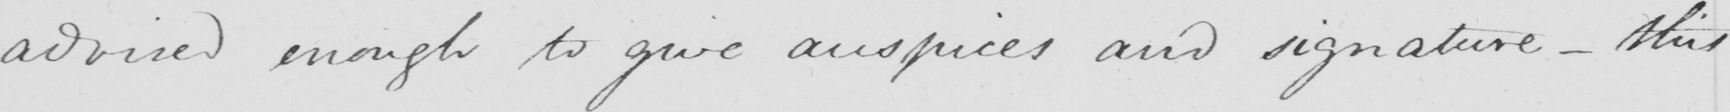Please transcribe the handwritten text in this image. advised enough to give auspices and signature  _  this 